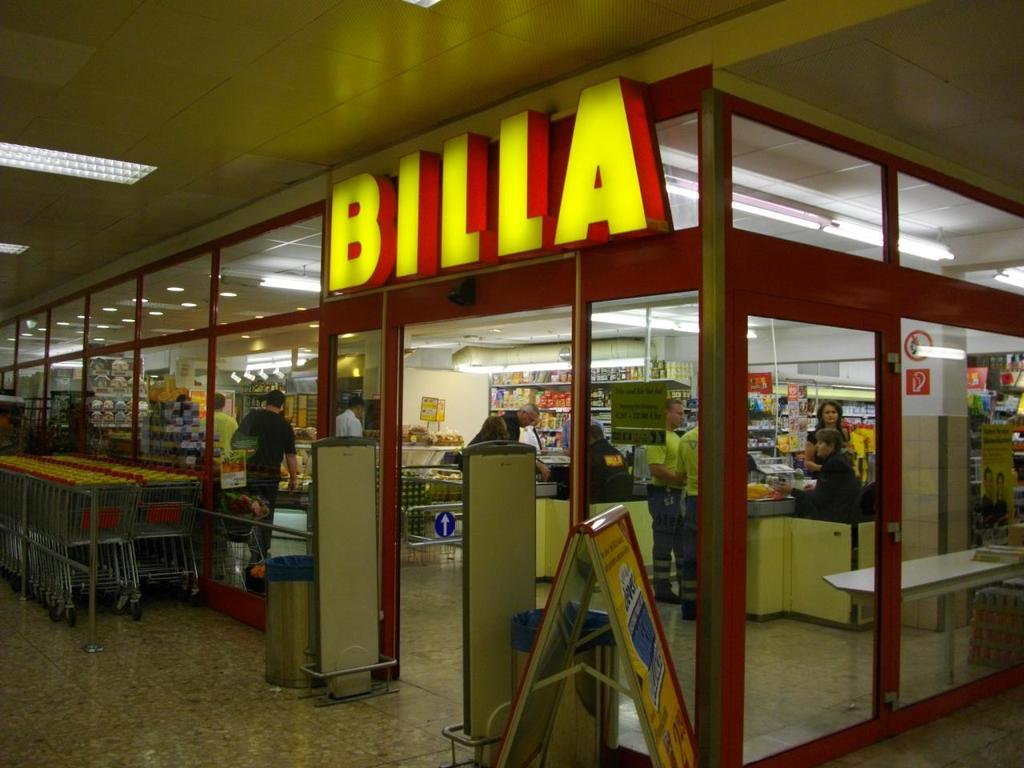<image>
Summarize the visual content of the image. store called billa with lots of people shopping inside 